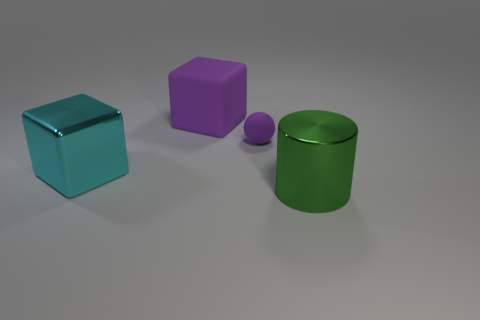Subtract all spheres. How many objects are left? 3 Add 2 green balls. How many objects exist? 6 Add 1 big green shiny balls. How many big green shiny balls exist? 1 Subtract 0 green balls. How many objects are left? 4 Subtract all big things. Subtract all big shiny cylinders. How many objects are left? 0 Add 2 tiny matte objects. How many tiny matte objects are left? 3 